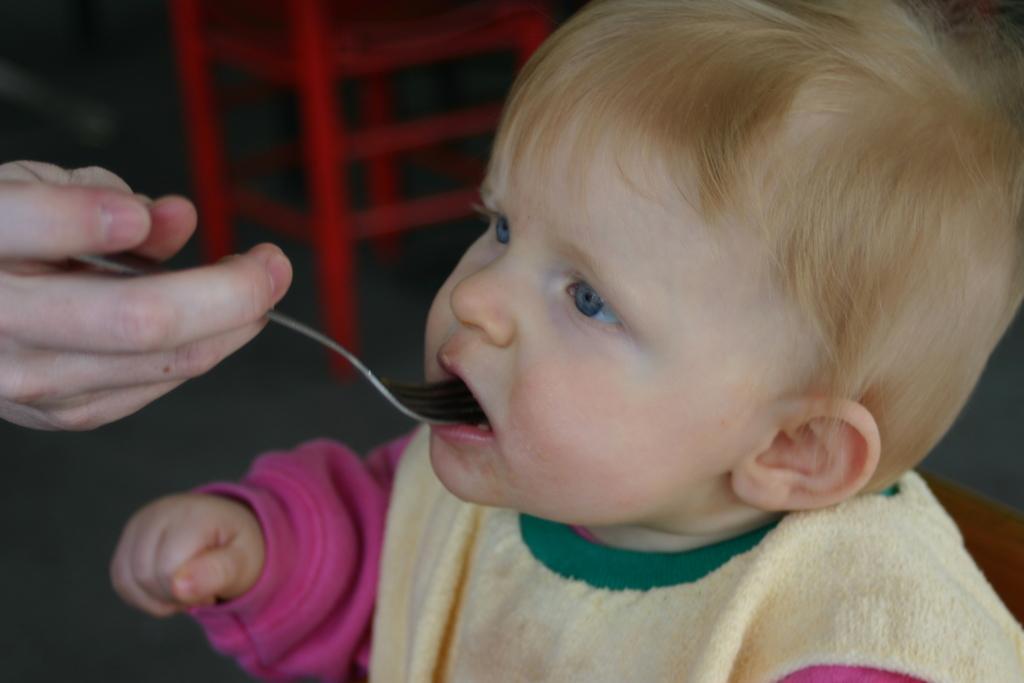Could you give a brief overview of what you see in this image? In this image I can see a baby facing towards the left side. On the left side there is a person's hand holding a spoon. It seems like this person is feeding to this baby. In the background there is a red color object in the dark. 